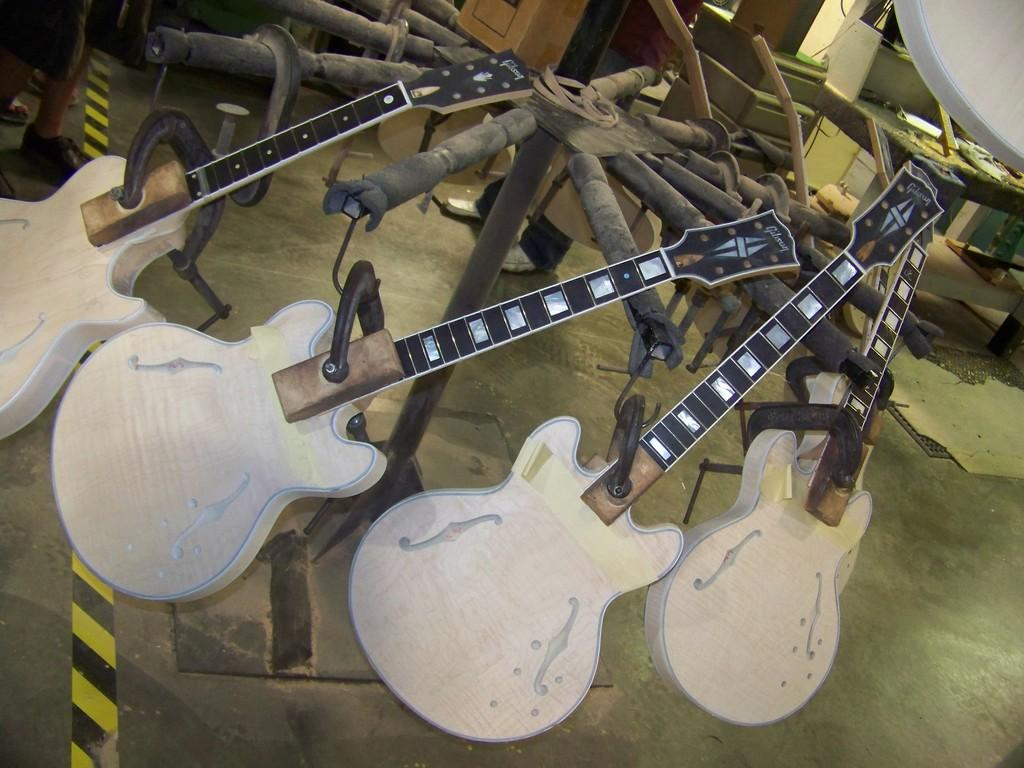What musical instruments are present in the image? There are guitars in the image. Can you describe the location of the table in the image? The table is on the right side of the image. What type of fruit is hanging from the branch in the image? There is no branch or fruit present in the image; it features guitars and a table. What color is the glove on the guitarist's hand in the image? There is no glove or guitarist present in the image; it only features guitars and a table. 